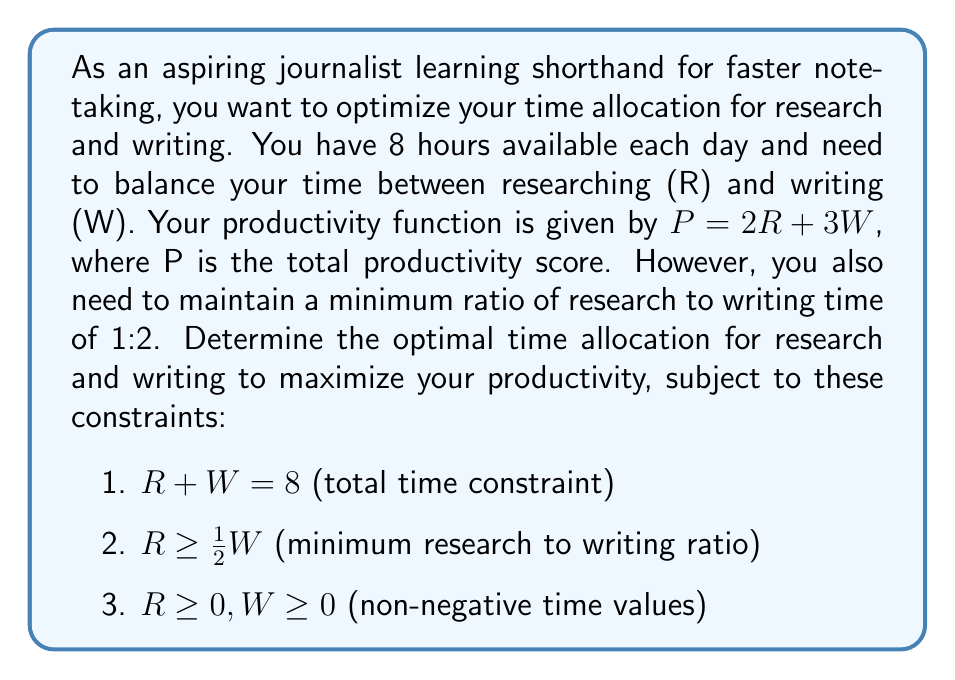Can you answer this question? To solve this optimization problem, we'll use the method of linear programming:

1. Define the objective function:
   $P = 2R + 3W$ (maximize this)

2. List the constraints:
   $R + W = 8$
   $R \geq \frac{1}{2}W$
   $R \geq 0, W \geq 0$

3. Graph the constraints:
   - $R + W = 8$ is a line
   - $R \geq \frac{1}{2}W$ is the area above the line $R = \frac{1}{2}W$
   - The non-negative constraints create the first quadrant

4. Identify the feasible region:
   The feasible region is a triangle bounded by $R + W = 8$, $R = \frac{1}{2}W$, and the y-axis.

5. Find the vertices of the feasible region:
   - (0, 8): intersection of $R + W = 8$ and y-axis
   - (8, 0): intersection of $R + W = 8$ and x-axis (not in feasible region)
   - (2.67, 5.33): intersection of $R + W = 8$ and $R = \frac{1}{2}W$

6. Evaluate the objective function at each vertex:
   - At (0, 8): $P = 2(0) + 3(8) = 24$
   - At (2.67, 5.33): $P = 2(2.67) + 3(5.33) \approx 21.33$

7. The maximum value occurs at (0, 8), but this doesn't satisfy the minimum research time constraint. Therefore, the optimal solution is at the intersection of $R + W = 8$ and $R = \frac{1}{2}W$.

8. Solve for the intersection:
   $R + W = 8$
   $R = \frac{1}{2}W$
   
   Substituting $R = \frac{1}{2}W$ into $R + W = 8$:
   $\frac{1}{2}W + W = 8$
   $\frac{3}{2}W = 8$
   $W = \frac{16}{3} \approx 5.33$
   
   Then, $R = \frac{1}{2}W = \frac{1}{2} \cdot \frac{16}{3} = \frac{8}{3} \approx 2.67$

Therefore, the optimal time allocation is approximately 2.67 hours for research and 5.33 hours for writing.
Answer: The optimal time allocation to maximize productivity is:
Research (R): $\frac{8}{3} \approx 2.67$ hours
Writing (W): $\frac{16}{3} \approx 5.33$ hours
Maximum productivity: $P = 2(\frac{8}{3}) + 3(\frac{16}{3}) = \frac{64}{3} \approx 21.33$ 